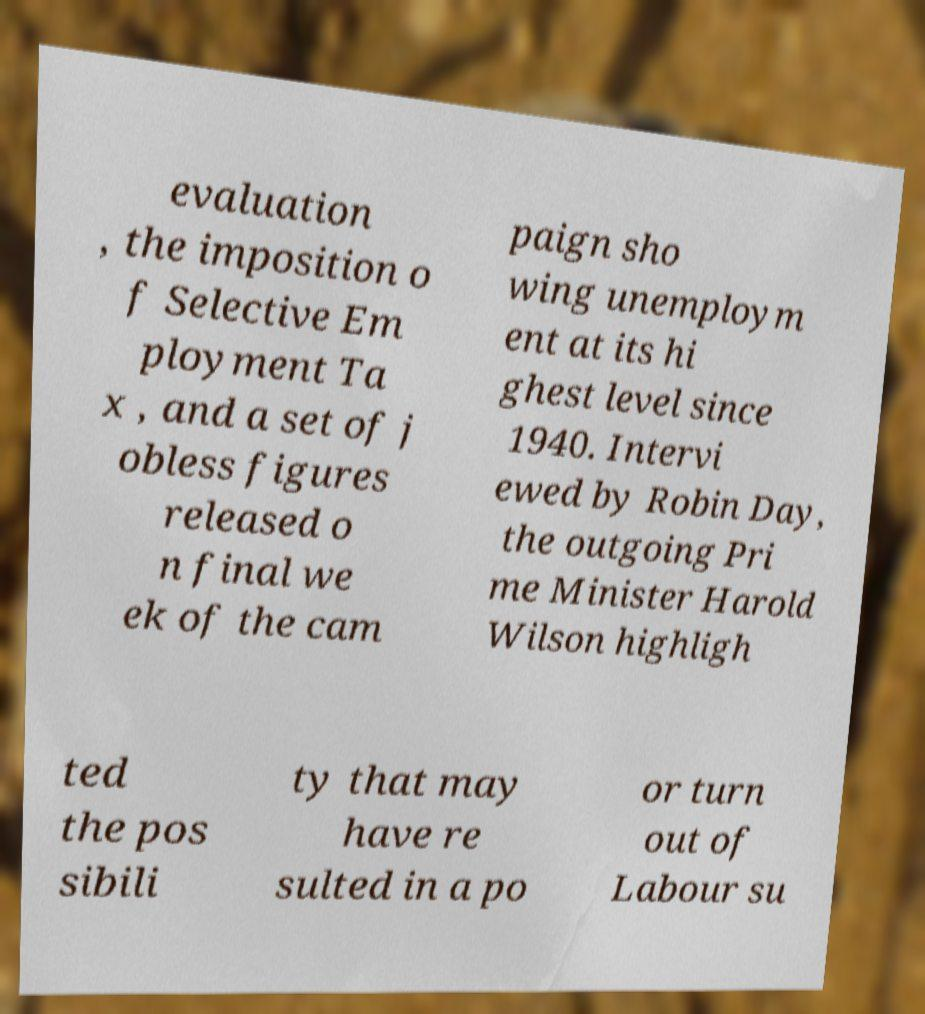Can you accurately transcribe the text from the provided image for me? evaluation , the imposition o f Selective Em ployment Ta x , and a set of j obless figures released o n final we ek of the cam paign sho wing unemploym ent at its hi ghest level since 1940. Intervi ewed by Robin Day, the outgoing Pri me Minister Harold Wilson highligh ted the pos sibili ty that may have re sulted in a po or turn out of Labour su 